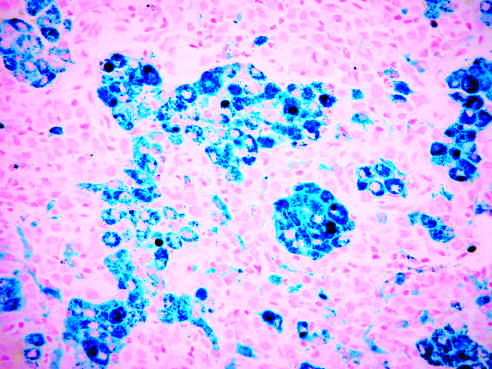what has the tissue been stained with?
Answer the question using a single word or phrase. Prussian blue 